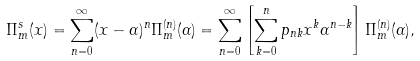<formula> <loc_0><loc_0><loc_500><loc_500>\Pi ^ { s } _ { m } ( x ) = \sum _ { n = 0 } ^ { \infty } ( x - \alpha ) ^ { n } \Pi ^ { ( n ) } _ { m } ( \alpha ) = \sum _ { n = 0 } ^ { \infty } \left [ \sum _ { k = 0 } ^ { n } p _ { n k } x ^ { k } \alpha ^ { n - k } \right ] \Pi ^ { ( n ) } _ { m } ( \alpha ) ,</formula> 